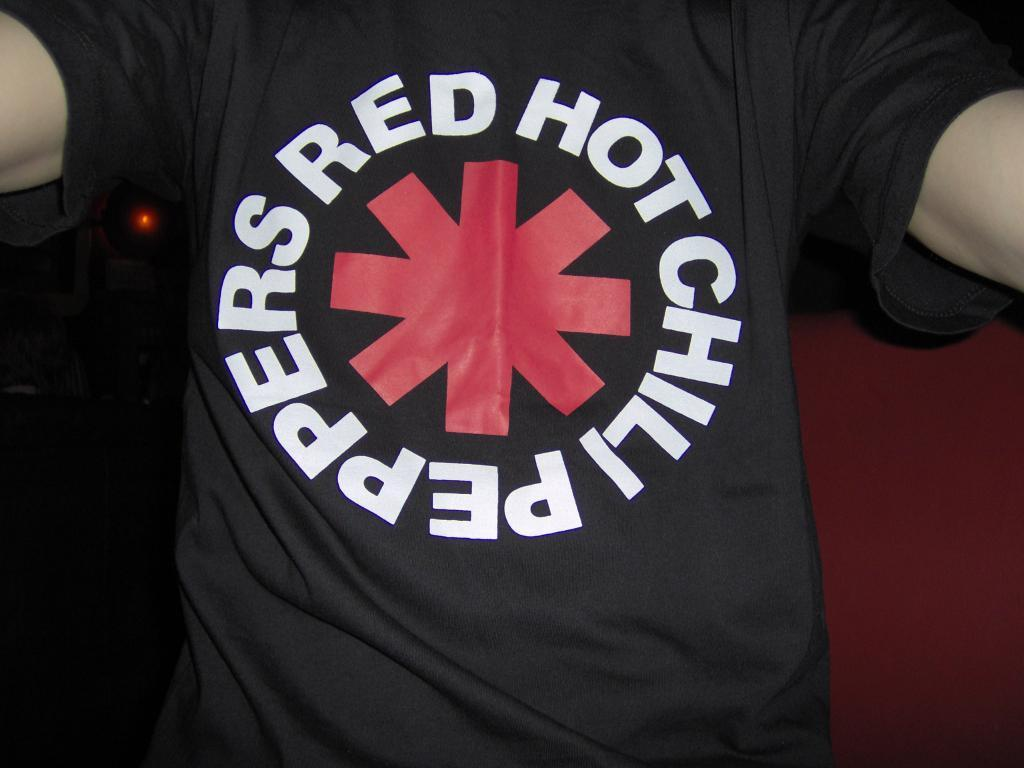Provide a one-sentence caption for the provided image. A man wearing a black Red Got Chili Peppers shirt. 